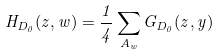Convert formula to latex. <formula><loc_0><loc_0><loc_500><loc_500>H _ { D _ { 0 } } ( z , w ) = \frac { 1 } { 4 } \sum _ { A _ { w } } G _ { D _ { 0 } } ( z , y )</formula> 